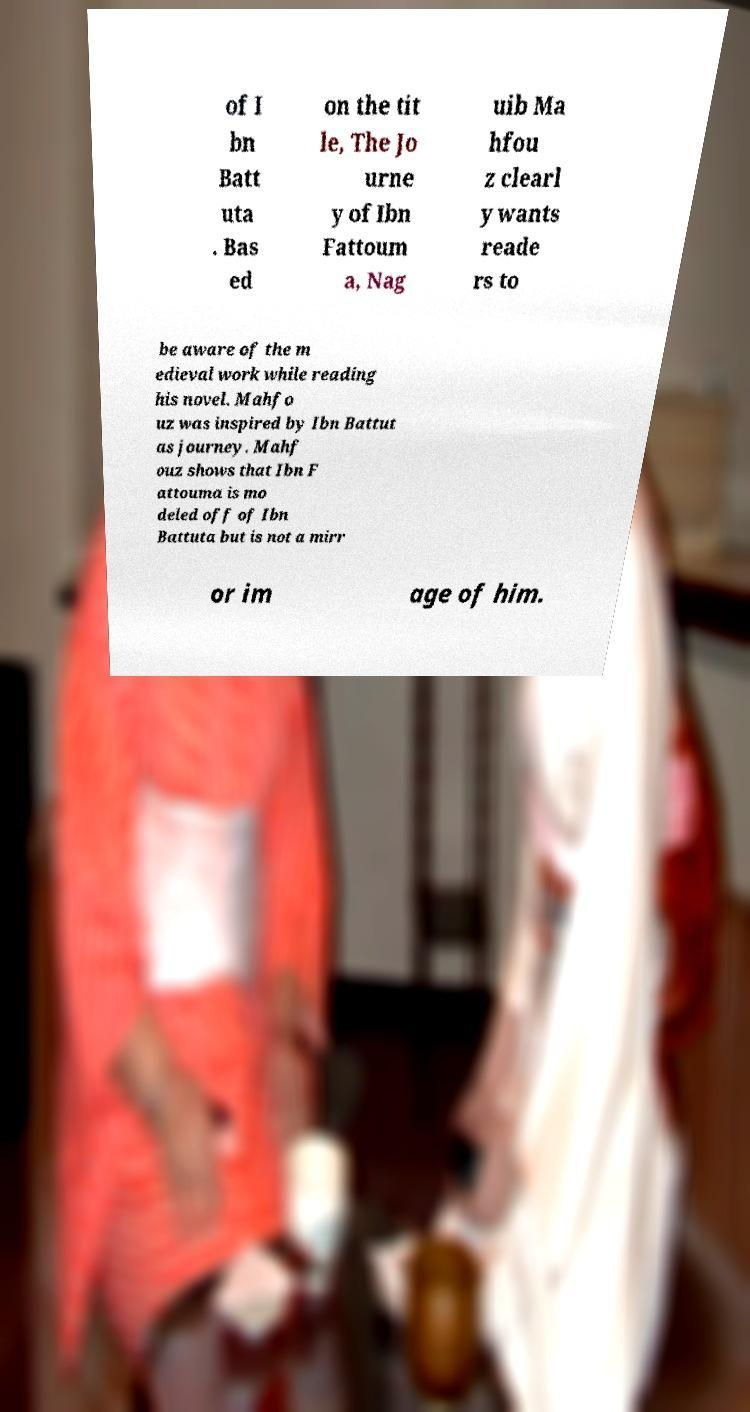Please identify and transcribe the text found in this image. of I bn Batt uta . Bas ed on the tit le, The Jo urne y of Ibn Fattoum a, Nag uib Ma hfou z clearl y wants reade rs to be aware of the m edieval work while reading his novel. Mahfo uz was inspired by Ibn Battut as journey. Mahf ouz shows that Ibn F attouma is mo deled off of Ibn Battuta but is not a mirr or im age of him. 